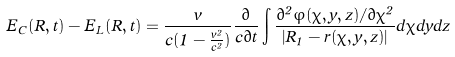Convert formula to latex. <formula><loc_0><loc_0><loc_500><loc_500>E _ { C } ( R , t ) - E _ { L } ( R , t ) = \frac { v } { c ( 1 - \frac { v ^ { 2 } } { c ^ { 2 } } ) } \frac { \partial } { c \partial t } \int \frac { \partial ^ { 2 } \varphi ( \chi , y , z ) / \partial \chi ^ { 2 } } { \left | R _ { 1 } - r ( \chi , y , z ) \right | } d \chi d y d z</formula> 